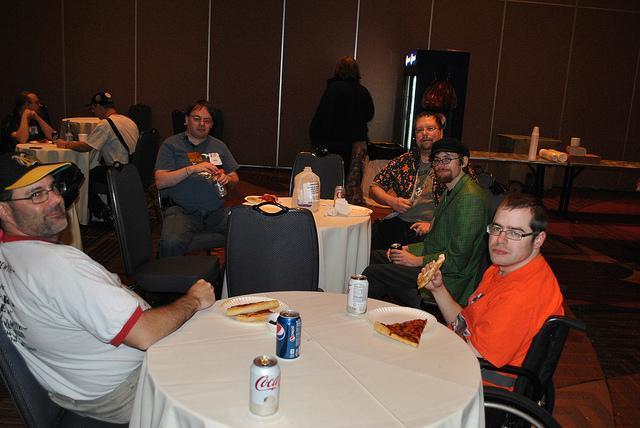How many wheelchairs?
Give a very brief answer. 1. How many dining tables can be seen?
Give a very brief answer. 2. How many chairs can be seen?
Give a very brief answer. 4. How many people are in the picture?
Give a very brief answer. 8. 